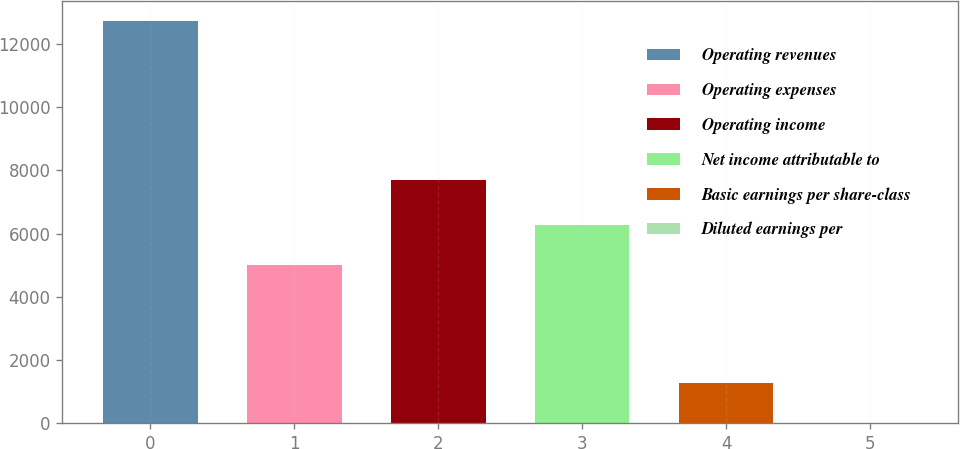<chart> <loc_0><loc_0><loc_500><loc_500><bar_chart><fcel>Operating revenues<fcel>Operating expenses<fcel>Operating income<fcel>Net income attributable to<fcel>Basic earnings per share-class<fcel>Diluted earnings per<nl><fcel>12702<fcel>5005<fcel>7697<fcel>6274.34<fcel>1277.96<fcel>8.62<nl></chart> 